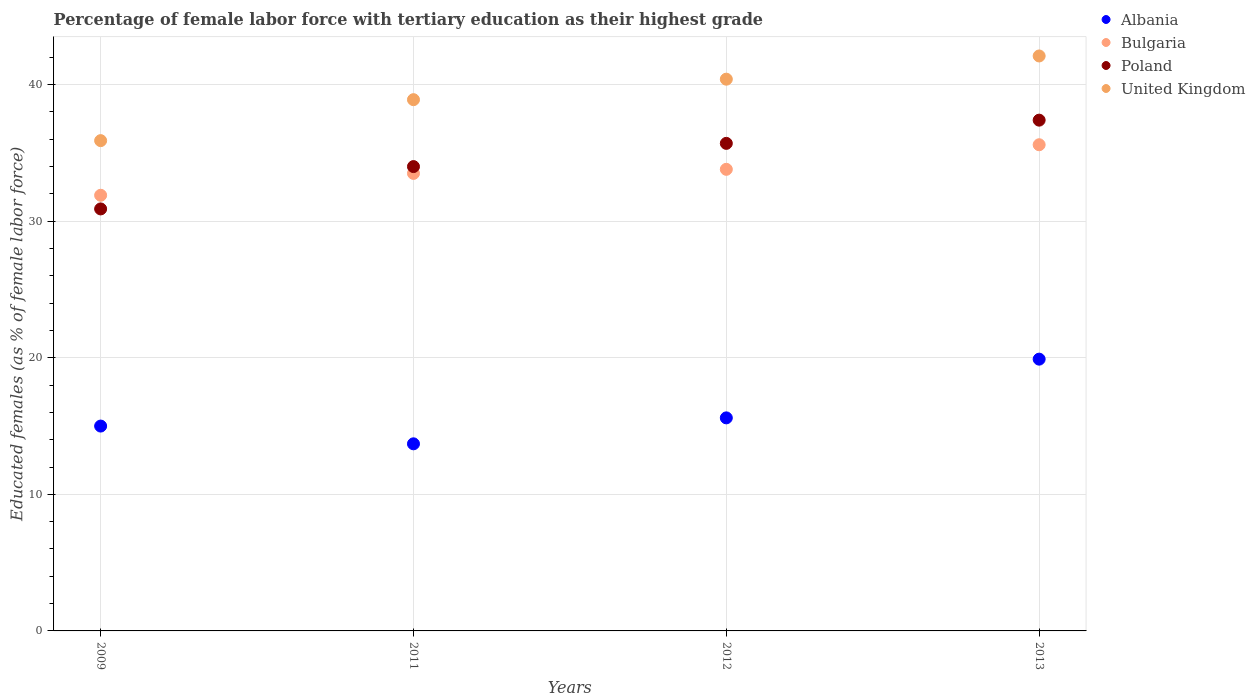Is the number of dotlines equal to the number of legend labels?
Give a very brief answer. Yes. What is the percentage of female labor force with tertiary education in Albania in 2013?
Give a very brief answer. 19.9. Across all years, what is the maximum percentage of female labor force with tertiary education in Bulgaria?
Offer a terse response. 35.6. Across all years, what is the minimum percentage of female labor force with tertiary education in Bulgaria?
Give a very brief answer. 31.9. In which year was the percentage of female labor force with tertiary education in Bulgaria minimum?
Your answer should be compact. 2009. What is the total percentage of female labor force with tertiary education in Poland in the graph?
Offer a very short reply. 138. What is the difference between the percentage of female labor force with tertiary education in Bulgaria in 2011 and that in 2012?
Your response must be concise. -0.3. What is the difference between the percentage of female labor force with tertiary education in Albania in 2011 and the percentage of female labor force with tertiary education in Bulgaria in 2012?
Make the answer very short. -20.1. What is the average percentage of female labor force with tertiary education in Bulgaria per year?
Make the answer very short. 33.7. In the year 2011, what is the difference between the percentage of female labor force with tertiary education in United Kingdom and percentage of female labor force with tertiary education in Albania?
Give a very brief answer. 25.2. What is the ratio of the percentage of female labor force with tertiary education in Bulgaria in 2009 to that in 2012?
Make the answer very short. 0.94. Is the difference between the percentage of female labor force with tertiary education in United Kingdom in 2009 and 2012 greater than the difference between the percentage of female labor force with tertiary education in Albania in 2009 and 2012?
Give a very brief answer. No. What is the difference between the highest and the second highest percentage of female labor force with tertiary education in Albania?
Make the answer very short. 4.3. What is the difference between the highest and the lowest percentage of female labor force with tertiary education in Albania?
Your answer should be compact. 6.2. In how many years, is the percentage of female labor force with tertiary education in Poland greater than the average percentage of female labor force with tertiary education in Poland taken over all years?
Keep it short and to the point. 2. Is the sum of the percentage of female labor force with tertiary education in Albania in 2009 and 2013 greater than the maximum percentage of female labor force with tertiary education in Bulgaria across all years?
Give a very brief answer. No. Is it the case that in every year, the sum of the percentage of female labor force with tertiary education in United Kingdom and percentage of female labor force with tertiary education in Poland  is greater than the sum of percentage of female labor force with tertiary education in Albania and percentage of female labor force with tertiary education in Bulgaria?
Provide a short and direct response. Yes. Is it the case that in every year, the sum of the percentage of female labor force with tertiary education in United Kingdom and percentage of female labor force with tertiary education in Albania  is greater than the percentage of female labor force with tertiary education in Bulgaria?
Ensure brevity in your answer.  Yes. Does the percentage of female labor force with tertiary education in Poland monotonically increase over the years?
Make the answer very short. Yes. How many dotlines are there?
Give a very brief answer. 4. How many years are there in the graph?
Provide a short and direct response. 4. What is the difference between two consecutive major ticks on the Y-axis?
Offer a very short reply. 10. Are the values on the major ticks of Y-axis written in scientific E-notation?
Keep it short and to the point. No. Does the graph contain grids?
Ensure brevity in your answer.  Yes. How many legend labels are there?
Offer a terse response. 4. What is the title of the graph?
Offer a very short reply. Percentage of female labor force with tertiary education as their highest grade. What is the label or title of the Y-axis?
Keep it short and to the point. Educated females (as % of female labor force). What is the Educated females (as % of female labor force) in Albania in 2009?
Ensure brevity in your answer.  15. What is the Educated females (as % of female labor force) of Bulgaria in 2009?
Make the answer very short. 31.9. What is the Educated females (as % of female labor force) of Poland in 2009?
Ensure brevity in your answer.  30.9. What is the Educated females (as % of female labor force) in United Kingdom in 2009?
Ensure brevity in your answer.  35.9. What is the Educated females (as % of female labor force) of Albania in 2011?
Provide a succinct answer. 13.7. What is the Educated females (as % of female labor force) of Bulgaria in 2011?
Your response must be concise. 33.5. What is the Educated females (as % of female labor force) in United Kingdom in 2011?
Provide a succinct answer. 38.9. What is the Educated females (as % of female labor force) of Albania in 2012?
Ensure brevity in your answer.  15.6. What is the Educated females (as % of female labor force) of Bulgaria in 2012?
Make the answer very short. 33.8. What is the Educated females (as % of female labor force) in Poland in 2012?
Provide a short and direct response. 35.7. What is the Educated females (as % of female labor force) in United Kingdom in 2012?
Offer a terse response. 40.4. What is the Educated females (as % of female labor force) in Albania in 2013?
Your answer should be compact. 19.9. What is the Educated females (as % of female labor force) in Bulgaria in 2013?
Give a very brief answer. 35.6. What is the Educated females (as % of female labor force) of Poland in 2013?
Your answer should be compact. 37.4. What is the Educated females (as % of female labor force) in United Kingdom in 2013?
Provide a succinct answer. 42.1. Across all years, what is the maximum Educated females (as % of female labor force) of Albania?
Your response must be concise. 19.9. Across all years, what is the maximum Educated females (as % of female labor force) of Bulgaria?
Your answer should be compact. 35.6. Across all years, what is the maximum Educated females (as % of female labor force) in Poland?
Your answer should be very brief. 37.4. Across all years, what is the maximum Educated females (as % of female labor force) in United Kingdom?
Provide a succinct answer. 42.1. Across all years, what is the minimum Educated females (as % of female labor force) in Albania?
Your answer should be compact. 13.7. Across all years, what is the minimum Educated females (as % of female labor force) of Bulgaria?
Make the answer very short. 31.9. Across all years, what is the minimum Educated females (as % of female labor force) in Poland?
Offer a terse response. 30.9. Across all years, what is the minimum Educated females (as % of female labor force) in United Kingdom?
Your response must be concise. 35.9. What is the total Educated females (as % of female labor force) of Albania in the graph?
Your response must be concise. 64.2. What is the total Educated females (as % of female labor force) in Bulgaria in the graph?
Give a very brief answer. 134.8. What is the total Educated females (as % of female labor force) of Poland in the graph?
Keep it short and to the point. 138. What is the total Educated females (as % of female labor force) in United Kingdom in the graph?
Offer a terse response. 157.3. What is the difference between the Educated females (as % of female labor force) in Albania in 2009 and that in 2011?
Make the answer very short. 1.3. What is the difference between the Educated females (as % of female labor force) of Poland in 2009 and that in 2011?
Offer a terse response. -3.1. What is the difference between the Educated females (as % of female labor force) of Poland in 2009 and that in 2012?
Offer a very short reply. -4.8. What is the difference between the Educated females (as % of female labor force) of Poland in 2009 and that in 2013?
Your answer should be compact. -6.5. What is the difference between the Educated females (as % of female labor force) of Albania in 2011 and that in 2012?
Make the answer very short. -1.9. What is the difference between the Educated females (as % of female labor force) of Bulgaria in 2011 and that in 2012?
Give a very brief answer. -0.3. What is the difference between the Educated females (as % of female labor force) of Poland in 2011 and that in 2012?
Offer a very short reply. -1.7. What is the difference between the Educated females (as % of female labor force) in United Kingdom in 2011 and that in 2012?
Provide a short and direct response. -1.5. What is the difference between the Educated females (as % of female labor force) in Albania in 2011 and that in 2013?
Make the answer very short. -6.2. What is the difference between the Educated females (as % of female labor force) in Poland in 2011 and that in 2013?
Keep it short and to the point. -3.4. What is the difference between the Educated females (as % of female labor force) in United Kingdom in 2011 and that in 2013?
Your response must be concise. -3.2. What is the difference between the Educated females (as % of female labor force) in Albania in 2009 and the Educated females (as % of female labor force) in Bulgaria in 2011?
Provide a succinct answer. -18.5. What is the difference between the Educated females (as % of female labor force) of Albania in 2009 and the Educated females (as % of female labor force) of United Kingdom in 2011?
Provide a short and direct response. -23.9. What is the difference between the Educated females (as % of female labor force) in Bulgaria in 2009 and the Educated females (as % of female labor force) in United Kingdom in 2011?
Provide a succinct answer. -7. What is the difference between the Educated females (as % of female labor force) in Albania in 2009 and the Educated females (as % of female labor force) in Bulgaria in 2012?
Offer a very short reply. -18.8. What is the difference between the Educated females (as % of female labor force) of Albania in 2009 and the Educated females (as % of female labor force) of Poland in 2012?
Give a very brief answer. -20.7. What is the difference between the Educated females (as % of female labor force) in Albania in 2009 and the Educated females (as % of female labor force) in United Kingdom in 2012?
Keep it short and to the point. -25.4. What is the difference between the Educated females (as % of female labor force) in Bulgaria in 2009 and the Educated females (as % of female labor force) in United Kingdom in 2012?
Offer a terse response. -8.5. What is the difference between the Educated females (as % of female labor force) in Albania in 2009 and the Educated females (as % of female labor force) in Bulgaria in 2013?
Keep it short and to the point. -20.6. What is the difference between the Educated females (as % of female labor force) of Albania in 2009 and the Educated females (as % of female labor force) of Poland in 2013?
Offer a very short reply. -22.4. What is the difference between the Educated females (as % of female labor force) of Albania in 2009 and the Educated females (as % of female labor force) of United Kingdom in 2013?
Offer a very short reply. -27.1. What is the difference between the Educated females (as % of female labor force) of Bulgaria in 2009 and the Educated females (as % of female labor force) of United Kingdom in 2013?
Make the answer very short. -10.2. What is the difference between the Educated females (as % of female labor force) of Poland in 2009 and the Educated females (as % of female labor force) of United Kingdom in 2013?
Keep it short and to the point. -11.2. What is the difference between the Educated females (as % of female labor force) of Albania in 2011 and the Educated females (as % of female labor force) of Bulgaria in 2012?
Offer a very short reply. -20.1. What is the difference between the Educated females (as % of female labor force) of Albania in 2011 and the Educated females (as % of female labor force) of Poland in 2012?
Give a very brief answer. -22. What is the difference between the Educated females (as % of female labor force) of Albania in 2011 and the Educated females (as % of female labor force) of United Kingdom in 2012?
Ensure brevity in your answer.  -26.7. What is the difference between the Educated females (as % of female labor force) of Bulgaria in 2011 and the Educated females (as % of female labor force) of Poland in 2012?
Your answer should be very brief. -2.2. What is the difference between the Educated females (as % of female labor force) of Albania in 2011 and the Educated females (as % of female labor force) of Bulgaria in 2013?
Make the answer very short. -21.9. What is the difference between the Educated females (as % of female labor force) in Albania in 2011 and the Educated females (as % of female labor force) in Poland in 2013?
Keep it short and to the point. -23.7. What is the difference between the Educated females (as % of female labor force) of Albania in 2011 and the Educated females (as % of female labor force) of United Kingdom in 2013?
Offer a terse response. -28.4. What is the difference between the Educated females (as % of female labor force) of Bulgaria in 2011 and the Educated females (as % of female labor force) of Poland in 2013?
Your answer should be very brief. -3.9. What is the difference between the Educated females (as % of female labor force) of Bulgaria in 2011 and the Educated females (as % of female labor force) of United Kingdom in 2013?
Ensure brevity in your answer.  -8.6. What is the difference between the Educated females (as % of female labor force) of Albania in 2012 and the Educated females (as % of female labor force) of Bulgaria in 2013?
Your answer should be compact. -20. What is the difference between the Educated females (as % of female labor force) in Albania in 2012 and the Educated females (as % of female labor force) in Poland in 2013?
Your answer should be compact. -21.8. What is the difference between the Educated females (as % of female labor force) of Albania in 2012 and the Educated females (as % of female labor force) of United Kingdom in 2013?
Ensure brevity in your answer.  -26.5. What is the difference between the Educated females (as % of female labor force) of Bulgaria in 2012 and the Educated females (as % of female labor force) of Poland in 2013?
Your response must be concise. -3.6. What is the difference between the Educated females (as % of female labor force) of Bulgaria in 2012 and the Educated females (as % of female labor force) of United Kingdom in 2013?
Offer a very short reply. -8.3. What is the average Educated females (as % of female labor force) in Albania per year?
Make the answer very short. 16.05. What is the average Educated females (as % of female labor force) in Bulgaria per year?
Keep it short and to the point. 33.7. What is the average Educated females (as % of female labor force) of Poland per year?
Offer a very short reply. 34.5. What is the average Educated females (as % of female labor force) in United Kingdom per year?
Give a very brief answer. 39.33. In the year 2009, what is the difference between the Educated females (as % of female labor force) of Albania and Educated females (as % of female labor force) of Bulgaria?
Offer a terse response. -16.9. In the year 2009, what is the difference between the Educated females (as % of female labor force) of Albania and Educated females (as % of female labor force) of Poland?
Offer a terse response. -15.9. In the year 2009, what is the difference between the Educated females (as % of female labor force) in Albania and Educated females (as % of female labor force) in United Kingdom?
Offer a terse response. -20.9. In the year 2011, what is the difference between the Educated females (as % of female labor force) in Albania and Educated females (as % of female labor force) in Bulgaria?
Give a very brief answer. -19.8. In the year 2011, what is the difference between the Educated females (as % of female labor force) of Albania and Educated females (as % of female labor force) of Poland?
Your answer should be compact. -20.3. In the year 2011, what is the difference between the Educated females (as % of female labor force) in Albania and Educated females (as % of female labor force) in United Kingdom?
Your answer should be very brief. -25.2. In the year 2011, what is the difference between the Educated females (as % of female labor force) in Bulgaria and Educated females (as % of female labor force) in Poland?
Provide a succinct answer. -0.5. In the year 2011, what is the difference between the Educated females (as % of female labor force) in Bulgaria and Educated females (as % of female labor force) in United Kingdom?
Your answer should be compact. -5.4. In the year 2011, what is the difference between the Educated females (as % of female labor force) in Poland and Educated females (as % of female labor force) in United Kingdom?
Ensure brevity in your answer.  -4.9. In the year 2012, what is the difference between the Educated females (as % of female labor force) in Albania and Educated females (as % of female labor force) in Bulgaria?
Give a very brief answer. -18.2. In the year 2012, what is the difference between the Educated females (as % of female labor force) of Albania and Educated females (as % of female labor force) of Poland?
Your answer should be compact. -20.1. In the year 2012, what is the difference between the Educated females (as % of female labor force) in Albania and Educated females (as % of female labor force) in United Kingdom?
Make the answer very short. -24.8. In the year 2012, what is the difference between the Educated females (as % of female labor force) in Bulgaria and Educated females (as % of female labor force) in United Kingdom?
Make the answer very short. -6.6. In the year 2012, what is the difference between the Educated females (as % of female labor force) of Poland and Educated females (as % of female labor force) of United Kingdom?
Your response must be concise. -4.7. In the year 2013, what is the difference between the Educated females (as % of female labor force) in Albania and Educated females (as % of female labor force) in Bulgaria?
Your answer should be compact. -15.7. In the year 2013, what is the difference between the Educated females (as % of female labor force) in Albania and Educated females (as % of female labor force) in Poland?
Ensure brevity in your answer.  -17.5. In the year 2013, what is the difference between the Educated females (as % of female labor force) in Albania and Educated females (as % of female labor force) in United Kingdom?
Provide a short and direct response. -22.2. In the year 2013, what is the difference between the Educated females (as % of female labor force) of Bulgaria and Educated females (as % of female labor force) of Poland?
Make the answer very short. -1.8. In the year 2013, what is the difference between the Educated females (as % of female labor force) of Bulgaria and Educated females (as % of female labor force) of United Kingdom?
Keep it short and to the point. -6.5. In the year 2013, what is the difference between the Educated females (as % of female labor force) in Poland and Educated females (as % of female labor force) in United Kingdom?
Offer a very short reply. -4.7. What is the ratio of the Educated females (as % of female labor force) in Albania in 2009 to that in 2011?
Your answer should be very brief. 1.09. What is the ratio of the Educated females (as % of female labor force) of Bulgaria in 2009 to that in 2011?
Ensure brevity in your answer.  0.95. What is the ratio of the Educated females (as % of female labor force) in Poland in 2009 to that in 2011?
Make the answer very short. 0.91. What is the ratio of the Educated females (as % of female labor force) in United Kingdom in 2009 to that in 2011?
Give a very brief answer. 0.92. What is the ratio of the Educated females (as % of female labor force) in Albania in 2009 to that in 2012?
Your response must be concise. 0.96. What is the ratio of the Educated females (as % of female labor force) in Bulgaria in 2009 to that in 2012?
Offer a terse response. 0.94. What is the ratio of the Educated females (as % of female labor force) in Poland in 2009 to that in 2012?
Offer a very short reply. 0.87. What is the ratio of the Educated females (as % of female labor force) in United Kingdom in 2009 to that in 2012?
Your response must be concise. 0.89. What is the ratio of the Educated females (as % of female labor force) of Albania in 2009 to that in 2013?
Your answer should be compact. 0.75. What is the ratio of the Educated females (as % of female labor force) in Bulgaria in 2009 to that in 2013?
Keep it short and to the point. 0.9. What is the ratio of the Educated females (as % of female labor force) of Poland in 2009 to that in 2013?
Your response must be concise. 0.83. What is the ratio of the Educated females (as % of female labor force) of United Kingdom in 2009 to that in 2013?
Give a very brief answer. 0.85. What is the ratio of the Educated females (as % of female labor force) in Albania in 2011 to that in 2012?
Give a very brief answer. 0.88. What is the ratio of the Educated females (as % of female labor force) in Bulgaria in 2011 to that in 2012?
Give a very brief answer. 0.99. What is the ratio of the Educated females (as % of female labor force) in United Kingdom in 2011 to that in 2012?
Offer a terse response. 0.96. What is the ratio of the Educated females (as % of female labor force) of Albania in 2011 to that in 2013?
Your response must be concise. 0.69. What is the ratio of the Educated females (as % of female labor force) of Bulgaria in 2011 to that in 2013?
Your response must be concise. 0.94. What is the ratio of the Educated females (as % of female labor force) of Poland in 2011 to that in 2013?
Your answer should be very brief. 0.91. What is the ratio of the Educated females (as % of female labor force) in United Kingdom in 2011 to that in 2013?
Keep it short and to the point. 0.92. What is the ratio of the Educated females (as % of female labor force) in Albania in 2012 to that in 2013?
Make the answer very short. 0.78. What is the ratio of the Educated females (as % of female labor force) of Bulgaria in 2012 to that in 2013?
Offer a terse response. 0.95. What is the ratio of the Educated females (as % of female labor force) of Poland in 2012 to that in 2013?
Ensure brevity in your answer.  0.95. What is the ratio of the Educated females (as % of female labor force) of United Kingdom in 2012 to that in 2013?
Make the answer very short. 0.96. What is the difference between the highest and the second highest Educated females (as % of female labor force) of United Kingdom?
Provide a short and direct response. 1.7. What is the difference between the highest and the lowest Educated females (as % of female labor force) in Bulgaria?
Your answer should be compact. 3.7. 